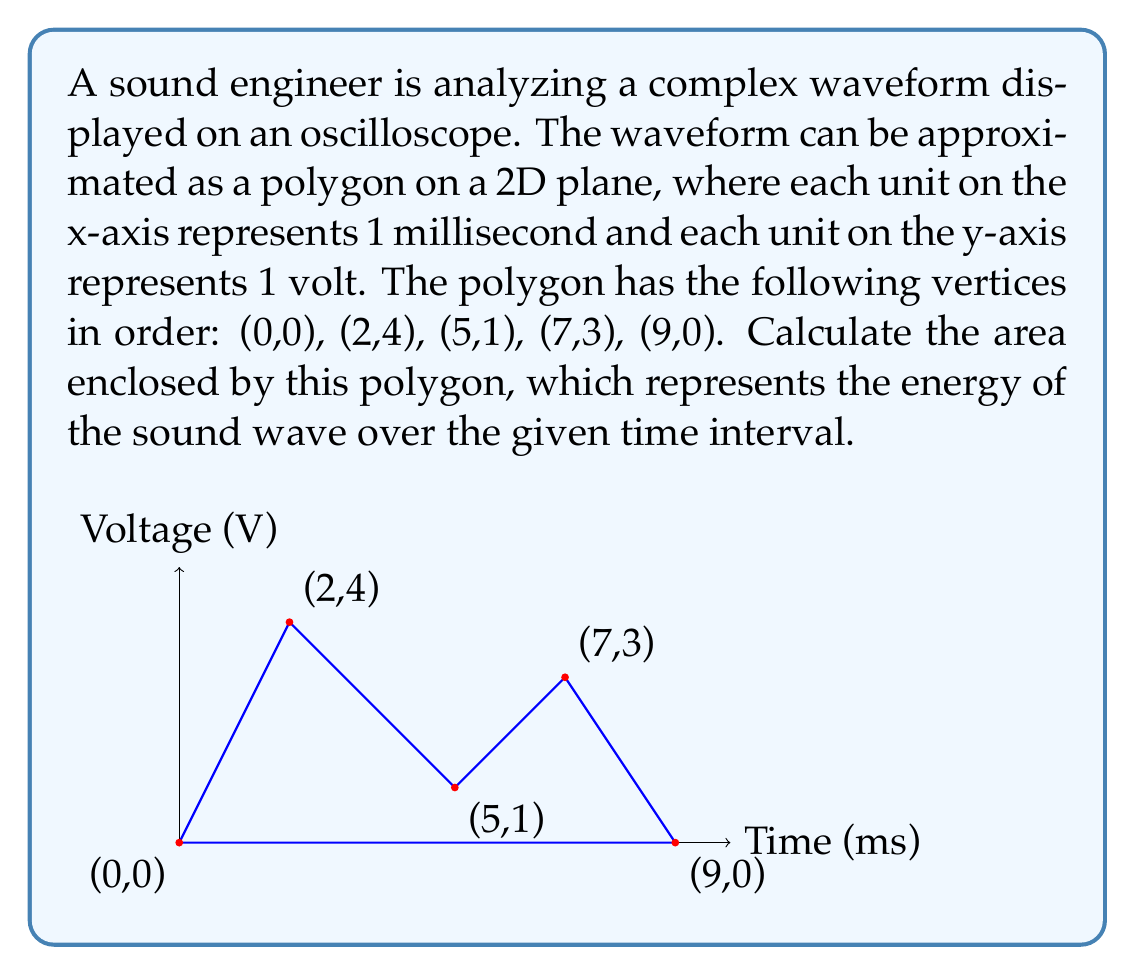Could you help me with this problem? To calculate the area of this complex polygon, we can use the Shoelace formula (also known as the surveyor's formula). This formula calculates the area of a polygon given the coordinates of its vertices.

The Shoelace formula is:

$$ A = \frac{1}{2}\left|\sum_{i=1}^{n-1} (x_iy_{i+1} + x_ny_1) - \sum_{i=1}^{n-1} (x_{i+1}y_i + x_1y_n)\right| $$

Where $(x_i, y_i)$ are the coordinates of the $i$-th vertex.

Let's apply this formula to our polygon:

1) First, let's list our vertices in order:
   $(x_1, y_1) = (0, 0)$
   $(x_2, y_2) = (2, 4)$
   $(x_3, y_3) = (5, 1)$
   $(x_4, y_4) = (7, 3)$
   $(x_5, y_5) = (9, 0)$

2) Now, let's calculate the first sum:
   $x_1y_2 + x_2y_3 + x_3y_4 + x_4y_5 + x_5y_1$
   $= 0(4) + 2(1) + 5(3) + 7(0) + 9(0) = 17$

3) Calculate the second sum:
   $x_2y_1 + x_3y_2 + x_4y_3 + x_5y_4 + x_1y_5$
   $= 2(0) + 5(4) + 7(1) + 9(3) + 0(0) = 47$

4) Subtract the second sum from the first:
   $17 - 47 = -30$

5) Take the absolute value and divide by 2:
   $\frac{1}{2}|-30| = 15$

Therefore, the area of the polygon is 15 square units.

In the context of sound engineering, this area represents 15 volt-milliseconds, which is a measure of the energy content of the sound wave over the 9-millisecond interval.
Answer: 15 volt-milliseconds 